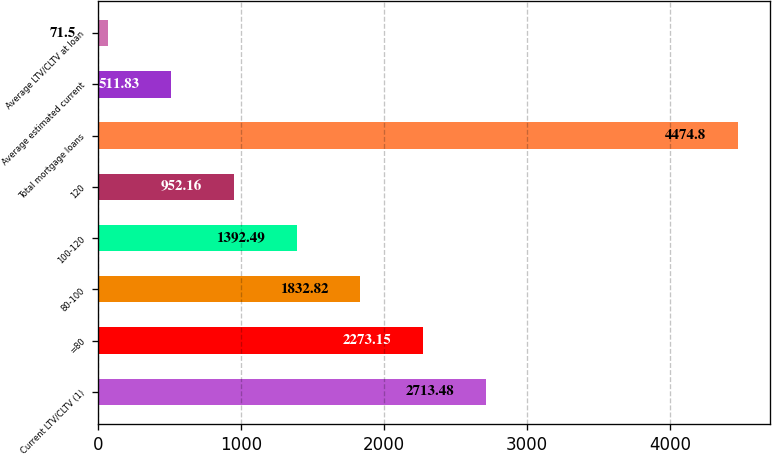Convert chart to OTSL. <chart><loc_0><loc_0><loc_500><loc_500><bar_chart><fcel>Current LTV/CLTV (1)<fcel>=80<fcel>80-100<fcel>100-120<fcel>120<fcel>Total mortgage loans<fcel>Average estimated current<fcel>Average LTV/CLTV at loan<nl><fcel>2713.48<fcel>2273.15<fcel>1832.82<fcel>1392.49<fcel>952.16<fcel>4474.8<fcel>511.83<fcel>71.5<nl></chart> 